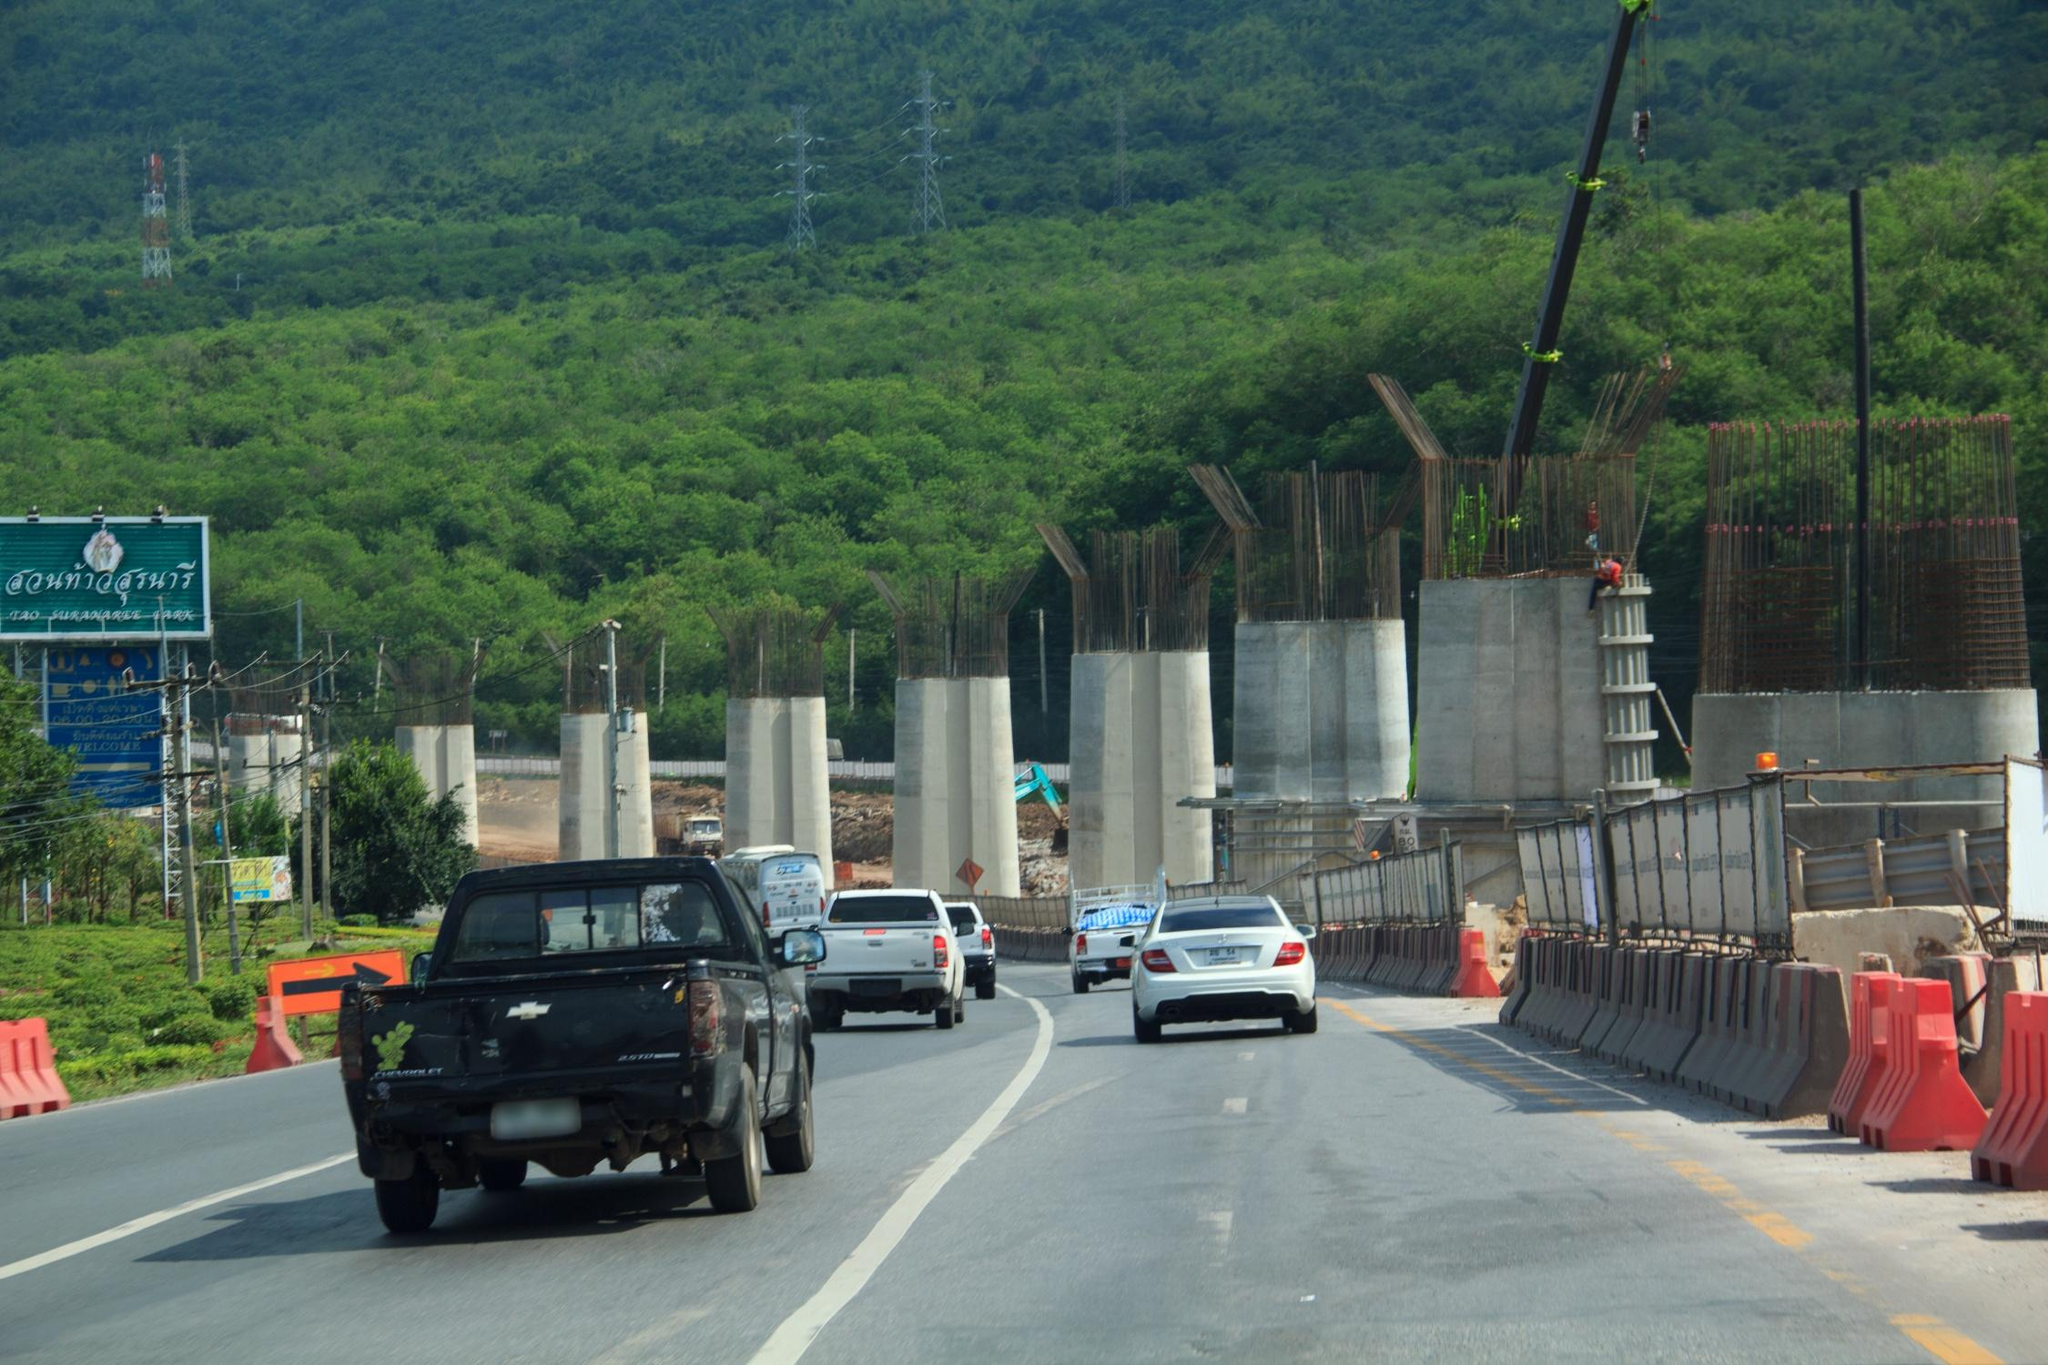In a short realistic scenario, how does the image reflect construction progress? The image vividly depicts significant progress in the construction of a highway through a mountainous region. The presence of multiple erected concrete pillars indicates foundational work for elevated sections of the road. Surrounding construction barriers and active machinery highlight ongoing efforts. This snapshot shows a crucial phase where the groundwork is in place, and the project is steadily advancing towards completion. 